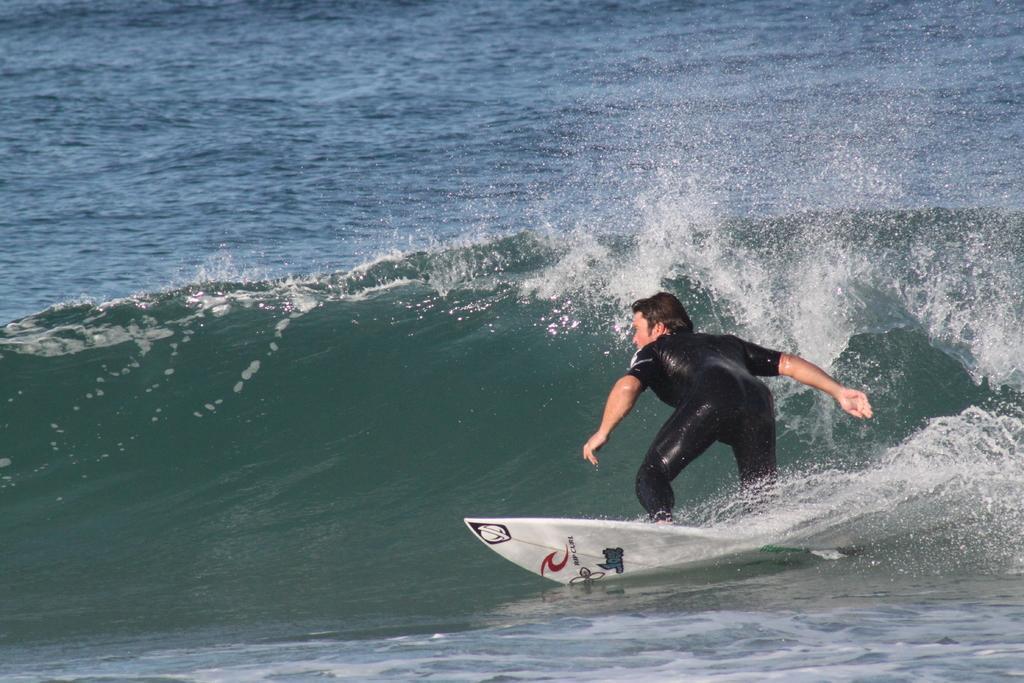Please provide a concise description of this image. In this picture I can see a person is doing surfing. The surfing board is white in color. The person is wearing black color suit. I can also see water. 